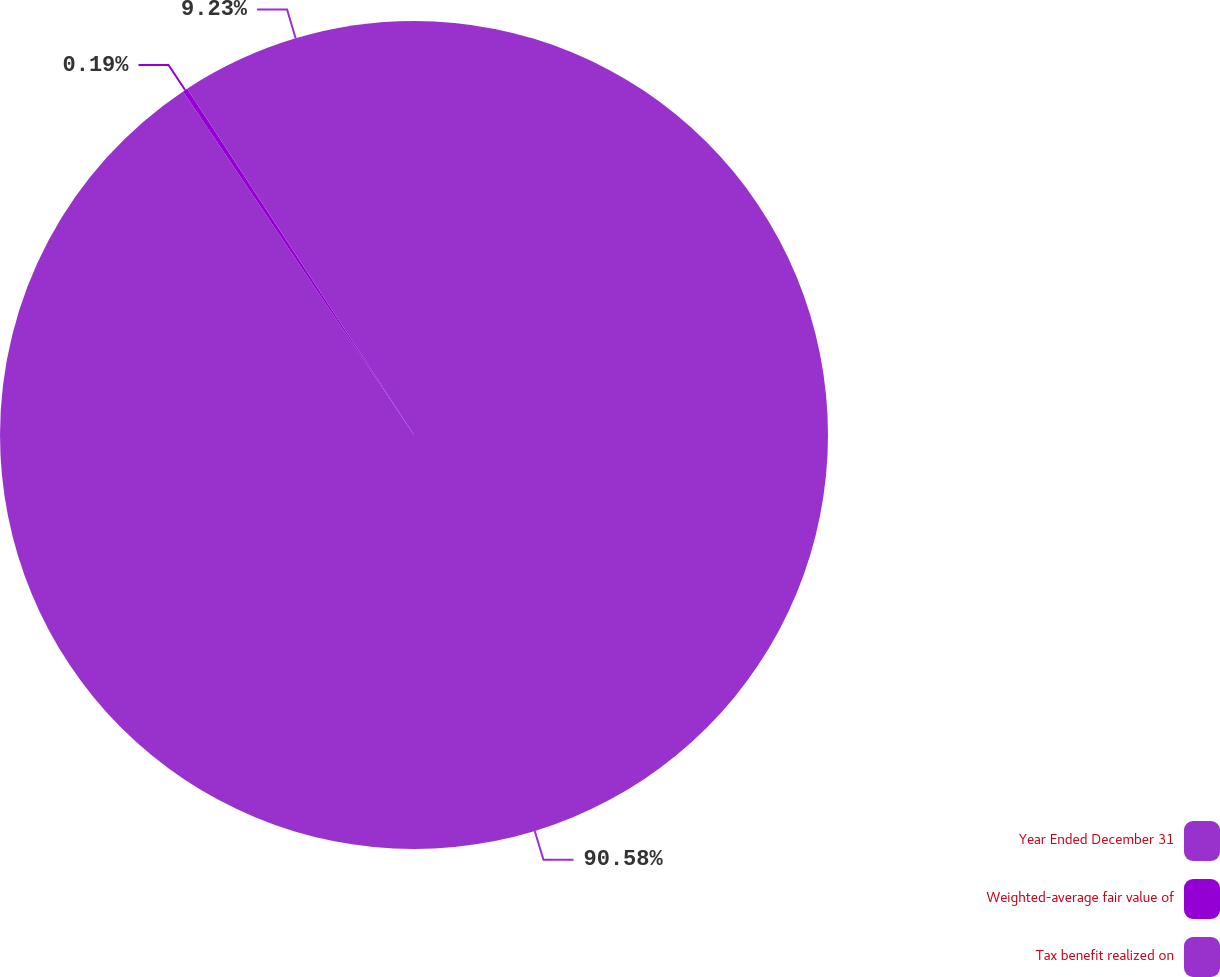<chart> <loc_0><loc_0><loc_500><loc_500><pie_chart><fcel>Year Ended December 31<fcel>Weighted-average fair value of<fcel>Tax benefit realized on<nl><fcel>90.59%<fcel>0.19%<fcel>9.23%<nl></chart> 